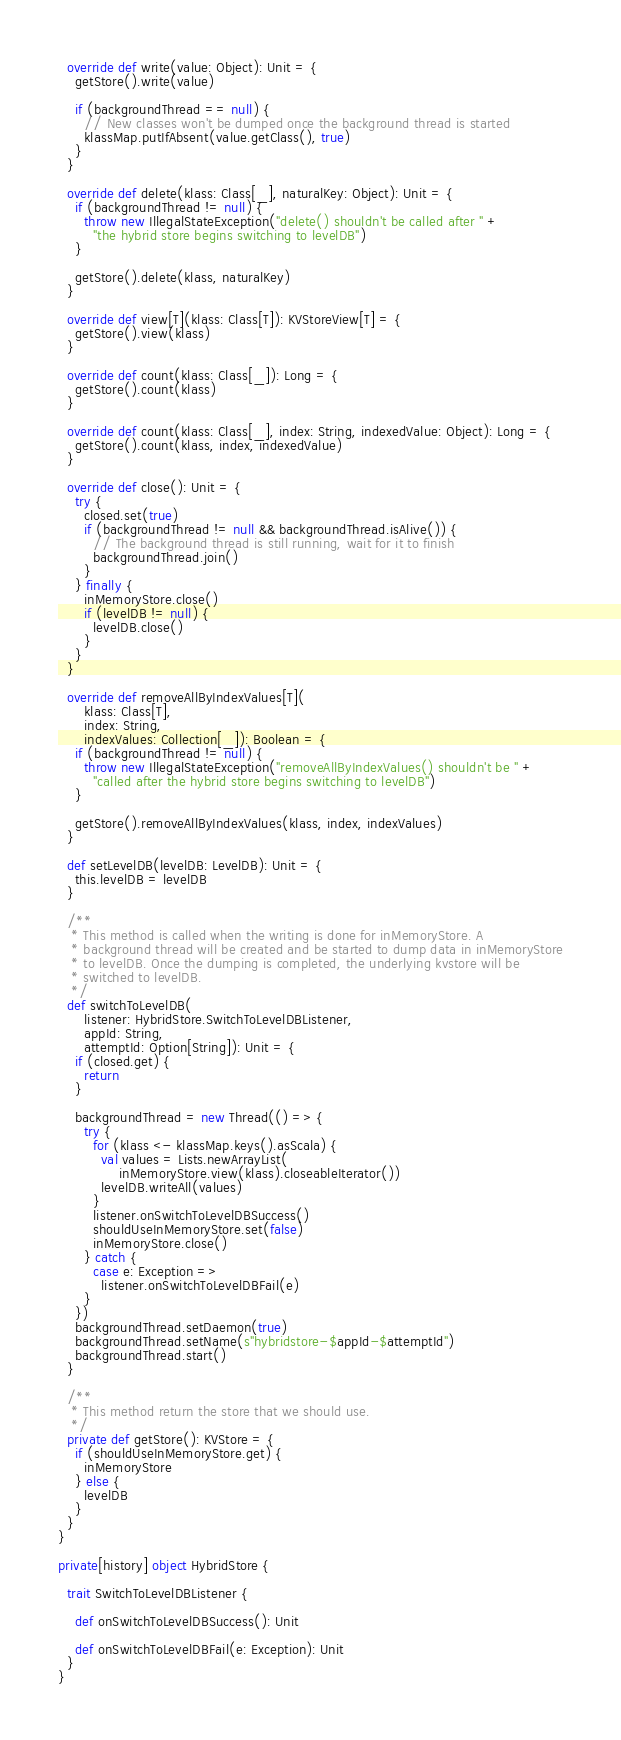Convert code to text. <code><loc_0><loc_0><loc_500><loc_500><_Scala_>  override def write(value: Object): Unit = {
    getStore().write(value)

    if (backgroundThread == null) {
      // New classes won't be dumped once the background thread is started
      klassMap.putIfAbsent(value.getClass(), true)
    }
  }

  override def delete(klass: Class[_], naturalKey: Object): Unit = {
    if (backgroundThread != null) {
      throw new IllegalStateException("delete() shouldn't be called after " +
        "the hybrid store begins switching to levelDB")
    }

    getStore().delete(klass, naturalKey)
  }

  override def view[T](klass: Class[T]): KVStoreView[T] = {
    getStore().view(klass)
  }

  override def count(klass: Class[_]): Long = {
    getStore().count(klass)
  }

  override def count(klass: Class[_], index: String, indexedValue: Object): Long = {
    getStore().count(klass, index, indexedValue)
  }

  override def close(): Unit = {
    try {
      closed.set(true)
      if (backgroundThread != null && backgroundThread.isAlive()) {
        // The background thread is still running, wait for it to finish
        backgroundThread.join()
      }
    } finally {
      inMemoryStore.close()
      if (levelDB != null) {
        levelDB.close()
      }
    }
  }

  override def removeAllByIndexValues[T](
      klass: Class[T],
      index: String,
      indexValues: Collection[_]): Boolean = {
    if (backgroundThread != null) {
      throw new IllegalStateException("removeAllByIndexValues() shouldn't be " +
        "called after the hybrid store begins switching to levelDB")
    }

    getStore().removeAllByIndexValues(klass, index, indexValues)
  }

  def setLevelDB(levelDB: LevelDB): Unit = {
    this.levelDB = levelDB
  }

  /**
   * This method is called when the writing is done for inMemoryStore. A
   * background thread will be created and be started to dump data in inMemoryStore
   * to levelDB. Once the dumping is completed, the underlying kvstore will be
   * switched to levelDB.
   */
  def switchToLevelDB(
      listener: HybridStore.SwitchToLevelDBListener,
      appId: String,
      attemptId: Option[String]): Unit = {
    if (closed.get) {
      return
    }

    backgroundThread = new Thread(() => {
      try {
        for (klass <- klassMap.keys().asScala) {
          val values = Lists.newArrayList(
              inMemoryStore.view(klass).closeableIterator())
          levelDB.writeAll(values)
        }
        listener.onSwitchToLevelDBSuccess()
        shouldUseInMemoryStore.set(false)
        inMemoryStore.close()
      } catch {
        case e: Exception =>
          listener.onSwitchToLevelDBFail(e)
      }
    })
    backgroundThread.setDaemon(true)
    backgroundThread.setName(s"hybridstore-$appId-$attemptId")
    backgroundThread.start()
  }

  /**
   * This method return the store that we should use.
   */
  private def getStore(): KVStore = {
    if (shouldUseInMemoryStore.get) {
      inMemoryStore
    } else {
      levelDB
    }
  }
}

private[history] object HybridStore {

  trait SwitchToLevelDBListener {

    def onSwitchToLevelDBSuccess(): Unit

    def onSwitchToLevelDBFail(e: Exception): Unit
  }
}
</code> 